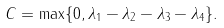<formula> <loc_0><loc_0><loc_500><loc_500>C = \max \{ 0 , \lambda _ { 1 } - \lambda _ { 2 } - \lambda _ { 3 } - \lambda _ { 4 } \} .</formula> 